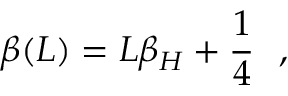<formula> <loc_0><loc_0><loc_500><loc_500>\beta ( L ) = L \beta _ { H } + { \frac { 1 } { 4 } } ,</formula> 